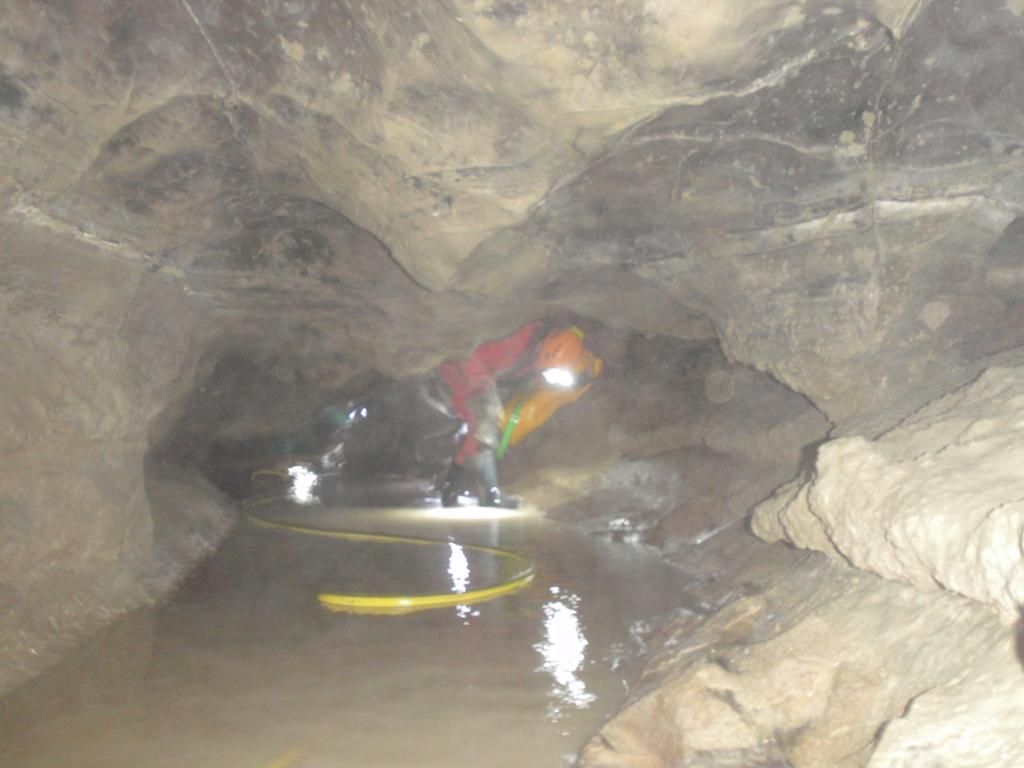Where is the location of the image? The image is underground. What can be seen at the top of the image? There are rocks at the top of the image. What are the people wearing in the image? The people in the image are wearing helmets. What is present in the image besides the people and rocks? There is a pipe and water in the image. Can you see a snail crawling on the rocks in the image? There is no snail present in the image; it only features rocks, people, a pipe, and water. What type of thunder can be heard in the image? There is no thunder present in the image, as it is underground and not an audible element. 